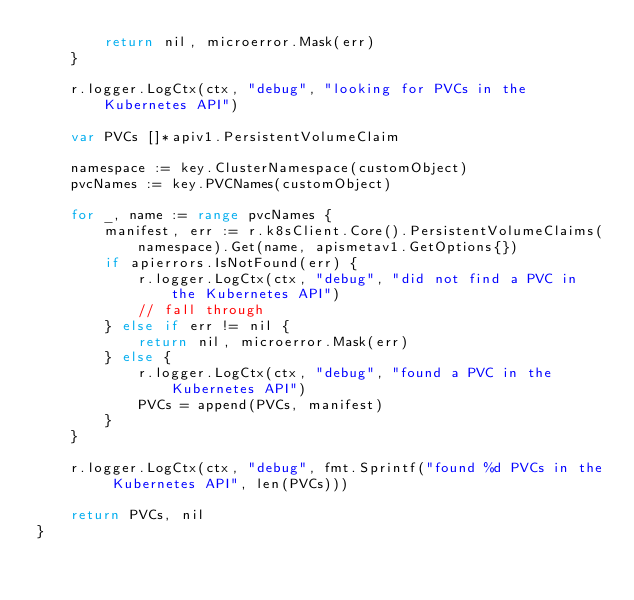Convert code to text. <code><loc_0><loc_0><loc_500><loc_500><_Go_>		return nil, microerror.Mask(err)
	}

	r.logger.LogCtx(ctx, "debug", "looking for PVCs in the Kubernetes API")

	var PVCs []*apiv1.PersistentVolumeClaim

	namespace := key.ClusterNamespace(customObject)
	pvcNames := key.PVCNames(customObject)

	for _, name := range pvcNames {
		manifest, err := r.k8sClient.Core().PersistentVolumeClaims(namespace).Get(name, apismetav1.GetOptions{})
		if apierrors.IsNotFound(err) {
			r.logger.LogCtx(ctx, "debug", "did not find a PVC in the Kubernetes API")
			// fall through
		} else if err != nil {
			return nil, microerror.Mask(err)
		} else {
			r.logger.LogCtx(ctx, "debug", "found a PVC in the Kubernetes API")
			PVCs = append(PVCs, manifest)
		}
	}

	r.logger.LogCtx(ctx, "debug", fmt.Sprintf("found %d PVCs in the Kubernetes API", len(PVCs)))

	return PVCs, nil
}
</code> 